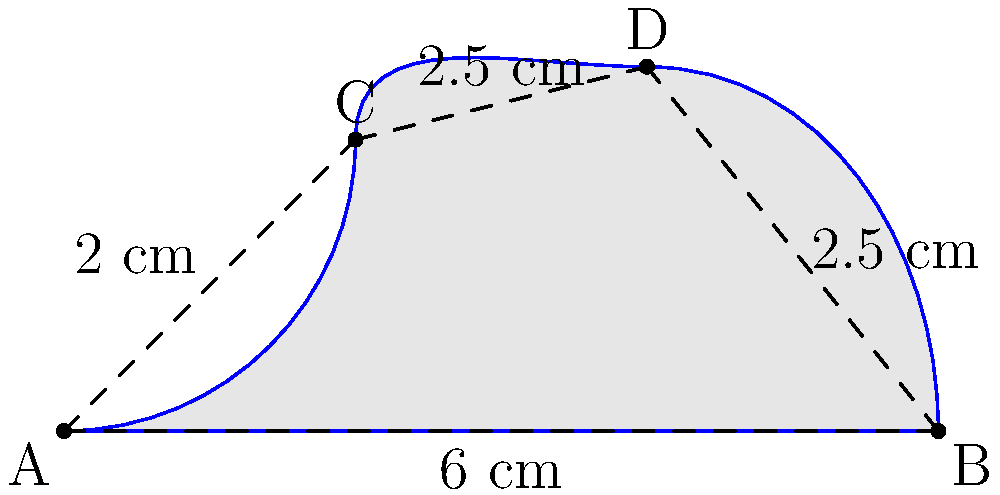As part of your mechanical engineering project, you need to calculate the area of a complex machine part with irregular curves. The part's shape is represented by the shaded region in the diagram above. The straight-line distances between points are given. Using numerical integration methods you've learned in your engineering courses, estimate the area of this part. Round your answer to the nearest 0.1 cm². To estimate the area of this irregular shape, we can use the trapezoidal rule for numerical integration. Here's how to approach this problem:

1) Divide the shape into three sections: A-C, C-D, and D-B.

2) For each section, we'll calculate the area as if it were a trapezoid:
   Area of trapezoid = $\frac{1}{2}(b_1 + b_2)h$, where $b_1$ and $b_2$ are the parallel sides and $h$ is the height.

3) Section A-C:
   Base = 2 cm, Height = 2 cm
   Area = $\frac{1}{2}(0 + 2) \cdot 2 = 2$ cm²

4) Section C-D:
   Bases = 2 cm and 2.5 cm, Height = 2.5 cm
   Area = $\frac{1}{2}(2 + 2.5) \cdot 2.5 = 5.625$ cm²

5) Section D-B:
   Base = 2.5 cm, Height = 2.5 cm
   Area = $\frac{1}{2}(2.5 + 0) \cdot 2.5 = 3.125$ cm²

6) Sum up all areas:
   Total Area = $2 + 5.625 + 3.125 = 10.75$ cm²

7) Round to the nearest 0.1 cm²:
   Final Answer = 10.8 cm²

This method provides an approximation of the true area. In a real engineering scenario, you might use more advanced numerical methods or computer-aided design (CAD) software for higher precision.
Answer: 10.8 cm² 